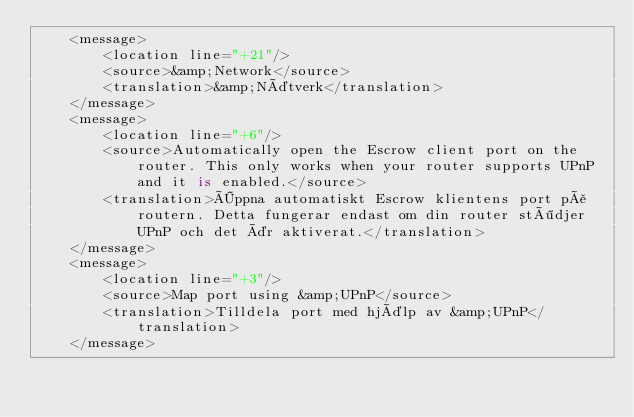<code> <loc_0><loc_0><loc_500><loc_500><_TypeScript_>    <message>
        <location line="+21"/>
        <source>&amp;Network</source>
        <translation>&amp;Nätverk</translation>
    </message>
    <message>
        <location line="+6"/>
        <source>Automatically open the Escrow client port on the router. This only works when your router supports UPnP and it is enabled.</source>
        <translation>Öppna automatiskt Escrow klientens port på routern. Detta fungerar endast om din router stödjer UPnP och det är aktiverat.</translation>
    </message>
    <message>
        <location line="+3"/>
        <source>Map port using &amp;UPnP</source>
        <translation>Tilldela port med hjälp av &amp;UPnP</translation>
    </message></code> 